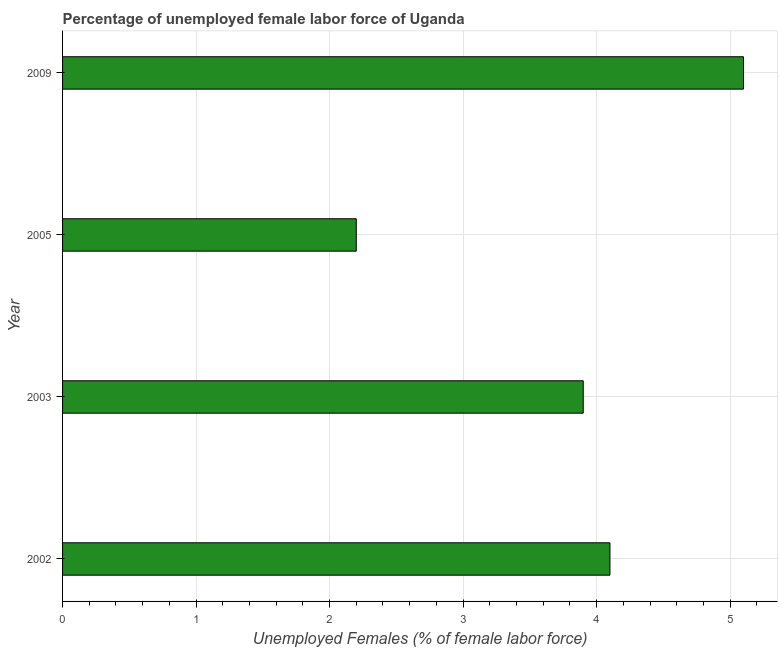Does the graph contain any zero values?
Offer a terse response. No. Does the graph contain grids?
Your answer should be very brief. Yes. What is the title of the graph?
Offer a very short reply. Percentage of unemployed female labor force of Uganda. What is the label or title of the X-axis?
Offer a terse response. Unemployed Females (% of female labor force). What is the total unemployed female labour force in 2003?
Provide a short and direct response. 3.9. Across all years, what is the maximum total unemployed female labour force?
Offer a terse response. 5.1. Across all years, what is the minimum total unemployed female labour force?
Your response must be concise. 2.2. What is the sum of the total unemployed female labour force?
Offer a terse response. 15.3. What is the difference between the total unemployed female labour force in 2002 and 2005?
Provide a short and direct response. 1.9. What is the average total unemployed female labour force per year?
Provide a short and direct response. 3.83. What is the median total unemployed female labour force?
Keep it short and to the point. 4. In how many years, is the total unemployed female labour force greater than 3.4 %?
Ensure brevity in your answer.  3. Do a majority of the years between 2002 and 2003 (inclusive) have total unemployed female labour force greater than 3.8 %?
Your response must be concise. Yes. What is the ratio of the total unemployed female labour force in 2005 to that in 2009?
Your response must be concise. 0.43. Is the difference between the total unemployed female labour force in 2002 and 2005 greater than the difference between any two years?
Offer a very short reply. No. How many bars are there?
Ensure brevity in your answer.  4. How many years are there in the graph?
Your answer should be compact. 4. Are the values on the major ticks of X-axis written in scientific E-notation?
Give a very brief answer. No. What is the Unemployed Females (% of female labor force) of 2002?
Your response must be concise. 4.1. What is the Unemployed Females (% of female labor force) of 2003?
Offer a very short reply. 3.9. What is the Unemployed Females (% of female labor force) in 2005?
Ensure brevity in your answer.  2.2. What is the Unemployed Females (% of female labor force) of 2009?
Provide a short and direct response. 5.1. What is the difference between the Unemployed Females (% of female labor force) in 2005 and 2009?
Your answer should be very brief. -2.9. What is the ratio of the Unemployed Females (% of female labor force) in 2002 to that in 2003?
Ensure brevity in your answer.  1.05. What is the ratio of the Unemployed Females (% of female labor force) in 2002 to that in 2005?
Ensure brevity in your answer.  1.86. What is the ratio of the Unemployed Females (% of female labor force) in 2002 to that in 2009?
Give a very brief answer. 0.8. What is the ratio of the Unemployed Females (% of female labor force) in 2003 to that in 2005?
Your response must be concise. 1.77. What is the ratio of the Unemployed Females (% of female labor force) in 2003 to that in 2009?
Keep it short and to the point. 0.77. What is the ratio of the Unemployed Females (% of female labor force) in 2005 to that in 2009?
Make the answer very short. 0.43. 